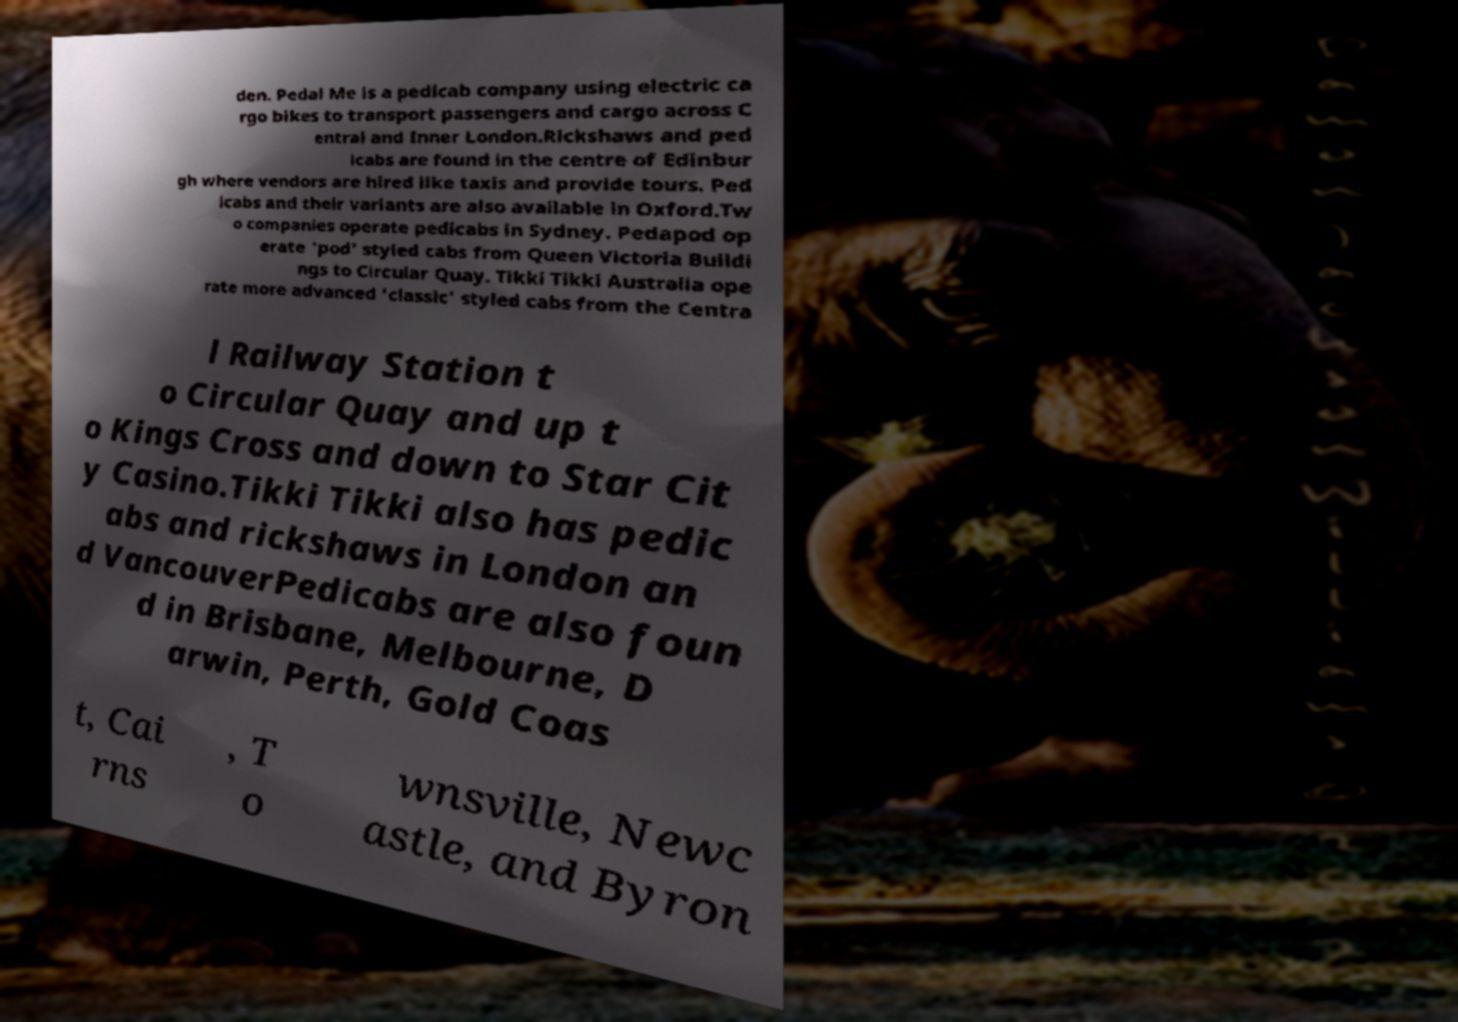Can you read and provide the text displayed in the image?This photo seems to have some interesting text. Can you extract and type it out for me? den. Pedal Me is a pedicab company using electric ca rgo bikes to transport passengers and cargo across C entral and Inner London.Rickshaws and ped icabs are found in the centre of Edinbur gh where vendors are hired like taxis and provide tours. Ped icabs and their variants are also available in Oxford.Tw o companies operate pedicabs in Sydney. Pedapod op erate 'pod' styled cabs from Queen Victoria Buildi ngs to Circular Quay. Tikki Tikki Australia ope rate more advanced 'classic' styled cabs from the Centra l Railway Station t o Circular Quay and up t o Kings Cross and down to Star Cit y Casino.Tikki Tikki also has pedic abs and rickshaws in London an d VancouverPedicabs are also foun d in Brisbane, Melbourne, D arwin, Perth, Gold Coas t, Cai rns , T o wnsville, Newc astle, and Byron 